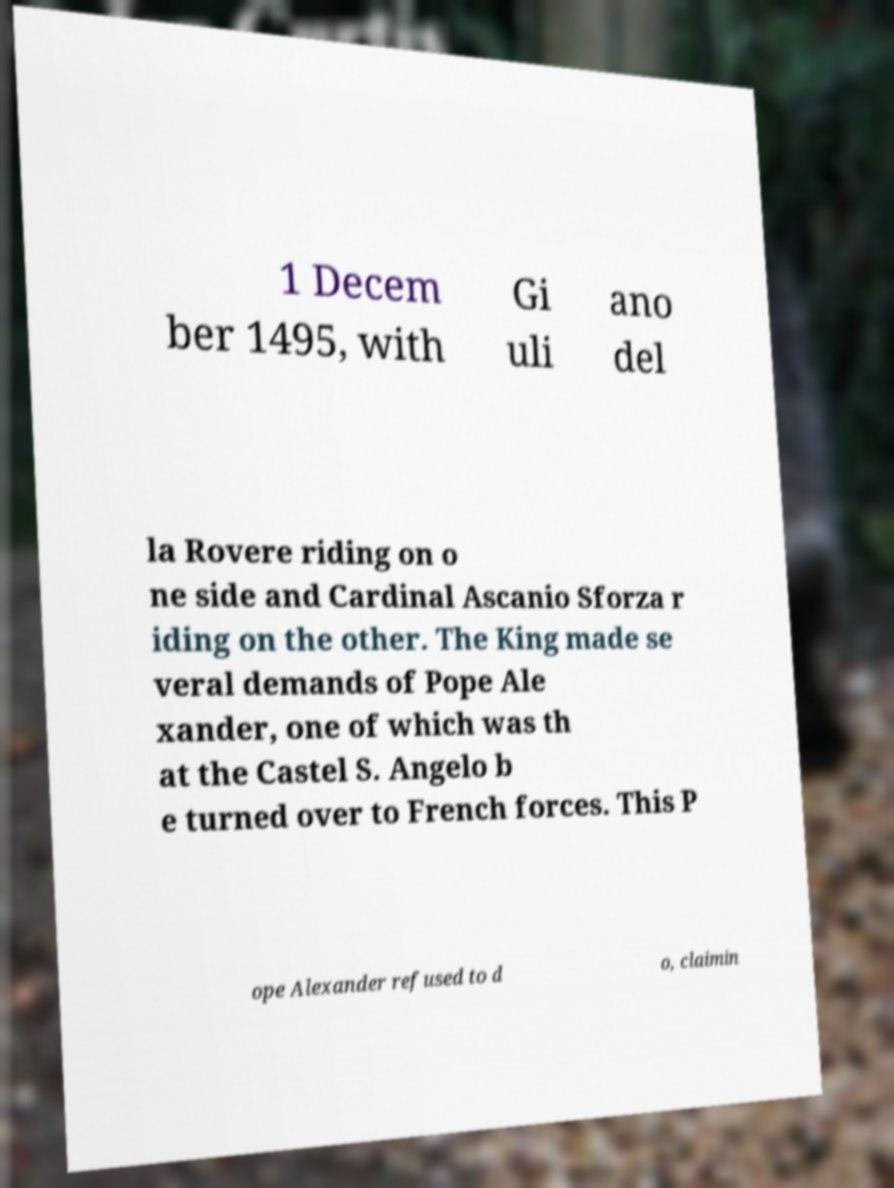Can you read and provide the text displayed in the image?This photo seems to have some interesting text. Can you extract and type it out for me? 1 Decem ber 1495, with Gi uli ano del la Rovere riding on o ne side and Cardinal Ascanio Sforza r iding on the other. The King made se veral demands of Pope Ale xander, one of which was th at the Castel S. Angelo b e turned over to French forces. This P ope Alexander refused to d o, claimin 